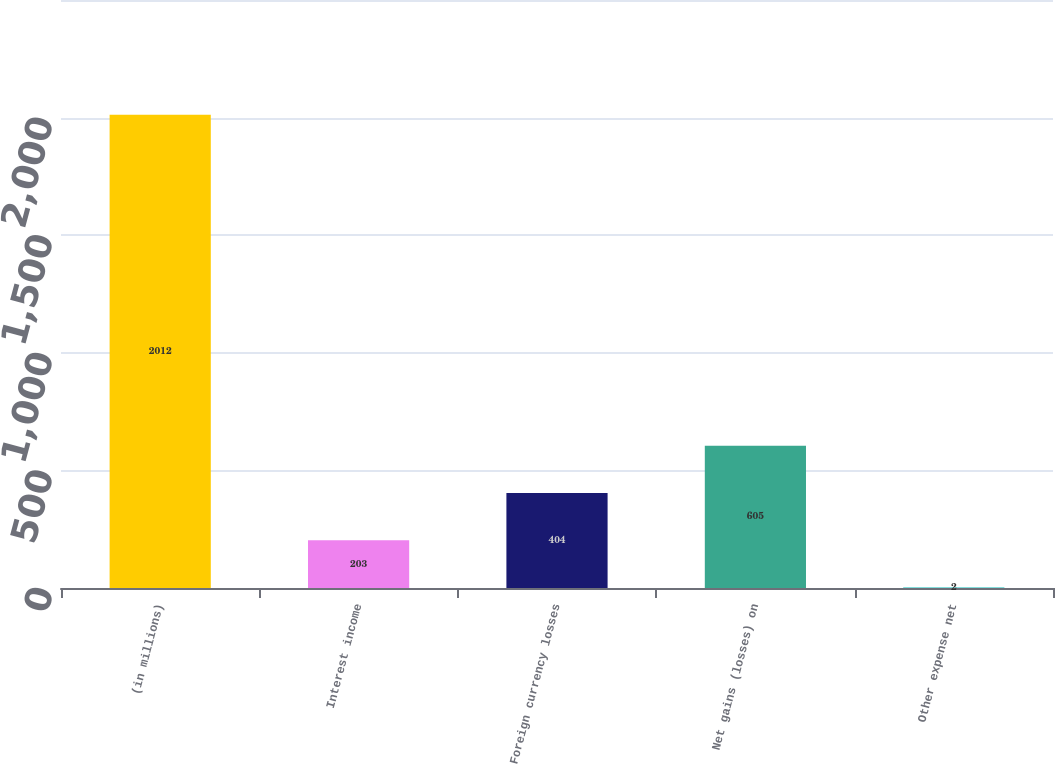<chart> <loc_0><loc_0><loc_500><loc_500><bar_chart><fcel>(in millions)<fcel>Interest income<fcel>Foreign currency losses<fcel>Net gains (losses) on<fcel>Other expense net<nl><fcel>2012<fcel>203<fcel>404<fcel>605<fcel>2<nl></chart> 